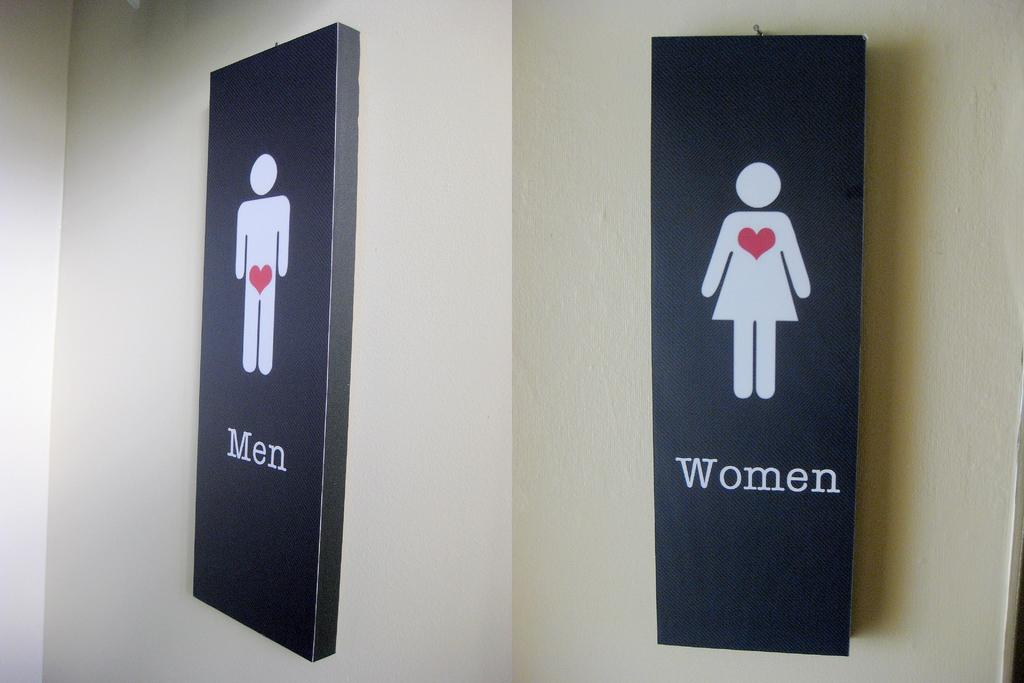What is the composition of the image? The image is a collage of two images. What objects are featured in the collage? There are two black color boards in the image. Where are the black color boards located? The black color boards are hanged on the walls. What is written or depicted on the black color boards? There is some text on the two boards. What is the color of the walls in the image? The walls are in cream color. What type of curtain is hanging in front of the black color boards? There is no curtain present in the image; the black color boards are hanged directly on the walls. 